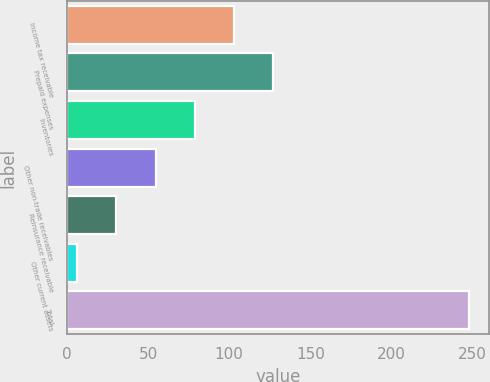Convert chart to OTSL. <chart><loc_0><loc_0><loc_500><loc_500><bar_chart><fcel>Income tax receivable<fcel>Prepaid expenses<fcel>Inventories<fcel>Other non-trade receivables<fcel>Reinsurance receivable<fcel>Other current assets<fcel>Total<nl><fcel>102.88<fcel>127<fcel>78.76<fcel>54.64<fcel>30.52<fcel>6.4<fcel>247.6<nl></chart> 